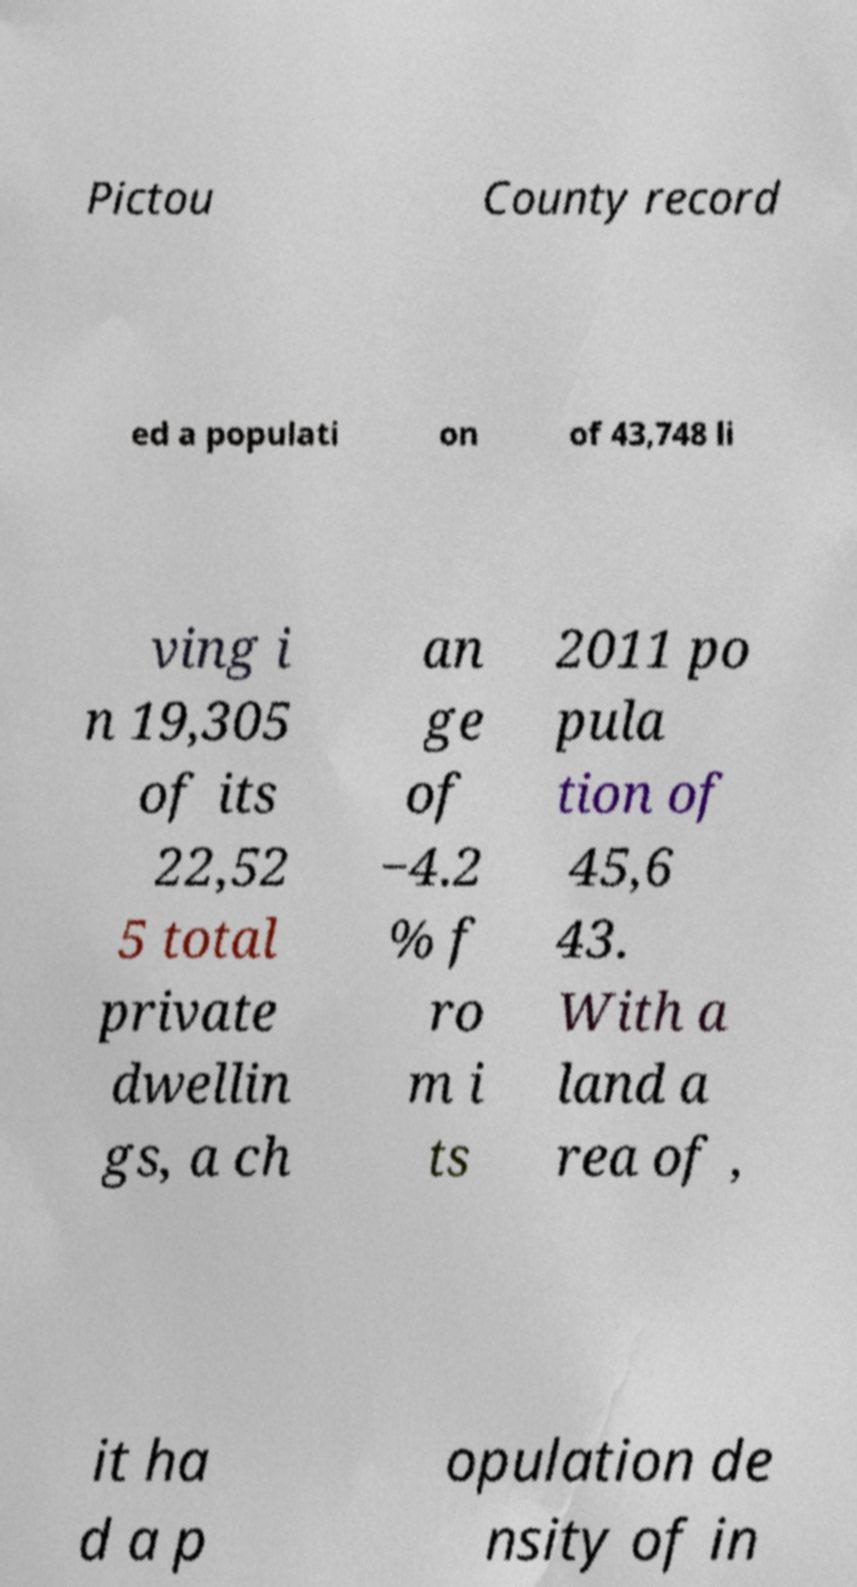There's text embedded in this image that I need extracted. Can you transcribe it verbatim? Pictou County record ed a populati on of 43,748 li ving i n 19,305 of its 22,52 5 total private dwellin gs, a ch an ge of −4.2 % f ro m i ts 2011 po pula tion of 45,6 43. With a land a rea of , it ha d a p opulation de nsity of in 